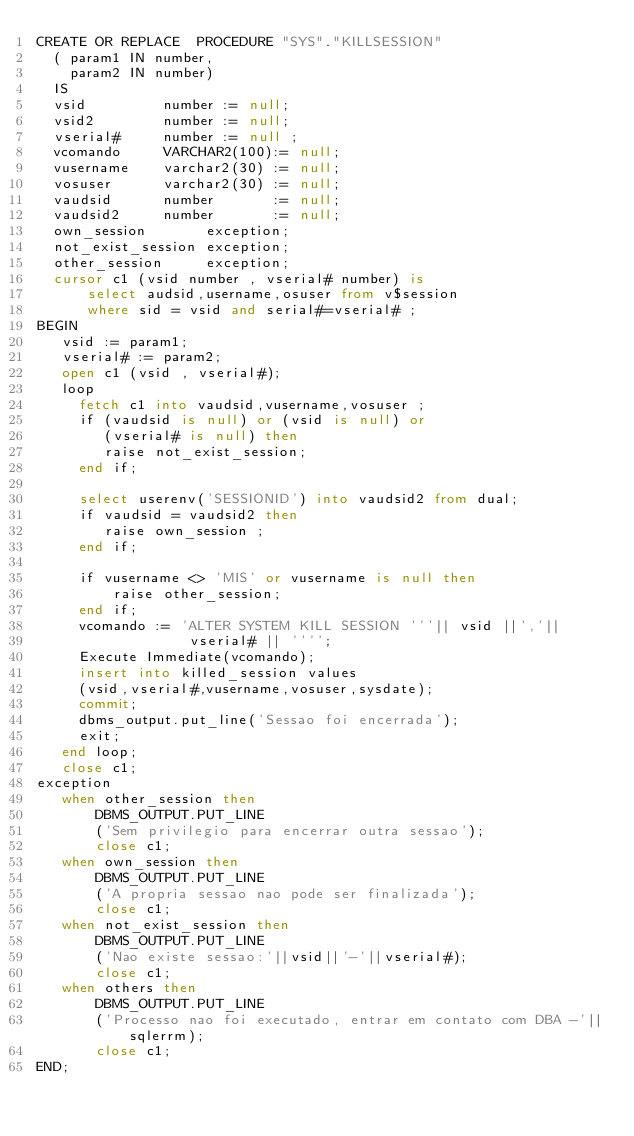<code> <loc_0><loc_0><loc_500><loc_500><_SQL_>CREATE OR REPLACE  PROCEDURE "SYS"."KILLSESSION" 
  ( param1 IN number,
    param2 IN number)
  IS
  vsid         number := null;
  vsid2        number := null;
  vserial#     number := null ;
  vcomando     VARCHAR2(100):= null;
  vusername    varchar2(30) := null;
  vosuser      varchar2(30) := null;
  vaudsid      number       := null;
  vaudsid2     number       := null;
  own_session       exception;
  not_exist_session exception;
  other_session     exception;
  cursor c1 (vsid number , vserial# number) is
      select audsid,username,osuser from v$session
      where sid = vsid and serial#=vserial# ;
BEGIN
   vsid := param1;
   vserial# := param2;
   open c1 (vsid , vserial#);
   loop
     fetch c1 into vaudsid,vusername,vosuser ;
     if (vaudsid is null) or (vsid is null) or
        (vserial# is null) then
        raise not_exist_session;
     end if;

     select userenv('SESSIONID') into vaudsid2 from dual;
     if vaudsid = vaudsid2 then
        raise own_session ;
     end if;

     if vusername <> 'MIS' or vusername is null then
         raise other_session;
     end if;
     vcomando := 'ALTER SYSTEM KILL SESSION '''|| vsid ||','||
                  vserial# || '''';
     Execute Immediate(vcomando);
     insert into killed_session values
     (vsid,vserial#,vusername,vosuser,sysdate);
     commit;
     dbms_output.put_line('Sessao foi encerrada');
     exit;
   end loop;
   close c1;
exception
   when other_session then
       DBMS_OUTPUT.PUT_LINE
       ('Sem privilegio para encerrar outra sessao');
       close c1;
   when own_session then
       DBMS_OUTPUT.PUT_LINE
       ('A propria sessao nao pode ser finalizada');
       close c1;
   when not_exist_session then
       DBMS_OUTPUT.PUT_LINE
       ('Nao existe sessao:'||vsid||'-'||vserial#);
       close c1;
   when others then
       DBMS_OUTPUT.PUT_LINE
       ('Processo nao foi executado, entrar em contato com DBA -'||sqlerrm);
       close c1;
END;
</code> 